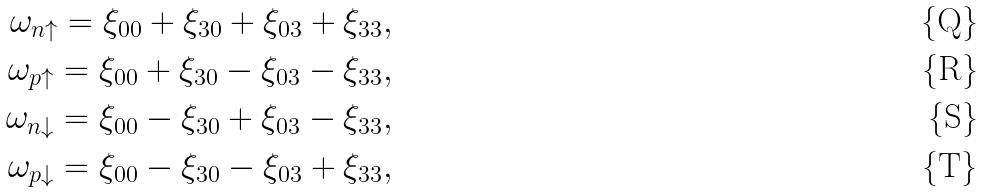<formula> <loc_0><loc_0><loc_500><loc_500>\omega _ { n \uparrow } = \xi _ { 0 0 } + \xi _ { 3 0 } + \xi _ { 0 3 } + \xi _ { 3 3 } , \, \\ \omega _ { p \uparrow } = \xi _ { 0 0 } + \xi _ { 3 0 } - \xi _ { 0 3 } - \xi _ { 3 3 } , \, \\ \omega _ { n \downarrow } = \xi _ { 0 0 } - \xi _ { 3 0 } + \xi _ { 0 3 } - \xi _ { 3 3 } , \, \\ \omega _ { p \downarrow } = \xi _ { 0 0 } - \xi _ { 3 0 } - \xi _ { 0 3 } + \xi _ { 3 3 } , \,</formula> 